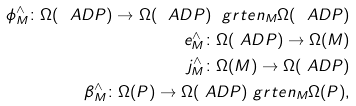Convert formula to latex. <formula><loc_0><loc_0><loc_500><loc_500>\phi ^ { \wedge } _ { M } \colon \Omega ( \ A D P ) \rightarrow \Omega ( \ A D P ) \ g r t e n _ { M } \Omega ( \ A D P ) \\ \ e ^ { \wedge } _ { M } \colon \Omega ( \ A D P ) \rightarrow \Omega ( M ) \\ j ^ { \wedge } _ { M } \colon \Omega ( M ) \rightarrow \Omega ( \ A D P ) \\ \beta ^ { \wedge } _ { M } \colon \Omega ( P ) \rightarrow \Omega ( \ A D P ) \ g r t e n _ { M } \Omega ( P ) ,</formula> 